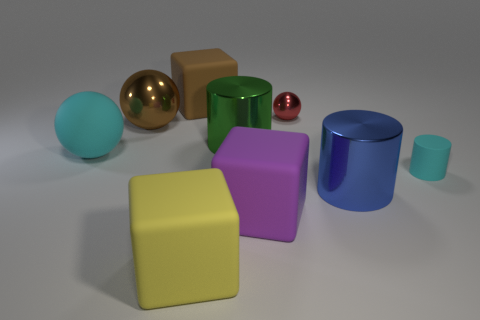Does the cylinder that is in front of the cyan matte cylinder have the same size as the brown matte cube?
Offer a terse response. Yes. What color is the big matte object left of the matte thing that is behind the sphere right of the yellow thing?
Give a very brief answer. Cyan. The small rubber thing has what color?
Provide a short and direct response. Cyan. Do the small metallic object and the small cylinder have the same color?
Offer a terse response. No. Is the cyan object right of the purple object made of the same material as the large cube that is behind the green object?
Provide a succinct answer. Yes. There is a large brown thing that is the same shape as the purple thing; what is it made of?
Provide a succinct answer. Rubber. Do the blue object and the tiny sphere have the same material?
Your answer should be compact. Yes. What is the color of the large cylinder behind the cyan rubber thing on the left side of the large brown rubber object?
Ensure brevity in your answer.  Green. There is a yellow cube that is the same material as the brown cube; what size is it?
Keep it short and to the point. Large. What number of brown objects have the same shape as the green thing?
Your answer should be very brief. 0. 